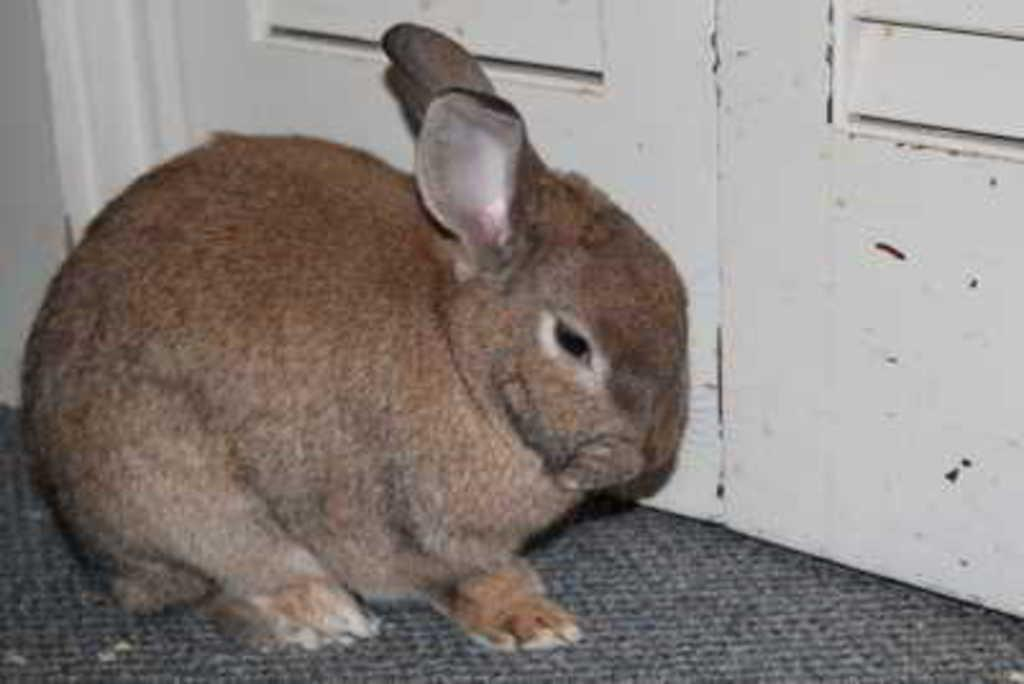What animal is on the floor in the image? There is a rabbit on the floor in the image. What can be seen in the background of the image? There is a door visible in the background of the image. What grade does the rabbit receive for its performance in the image? There is no indication of a performance or grading system in the image, as it simply features a rabbit on the floor and a door in the background. 